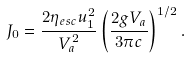<formula> <loc_0><loc_0><loc_500><loc_500>J _ { 0 } = \frac { 2 \eta _ { e s c } u _ { 1 } ^ { 2 } } { V _ { a } ^ { 2 } } \left ( \frac { 2 g V _ { a } } { 3 \pi c } \right ) ^ { 1 / 2 } .</formula> 